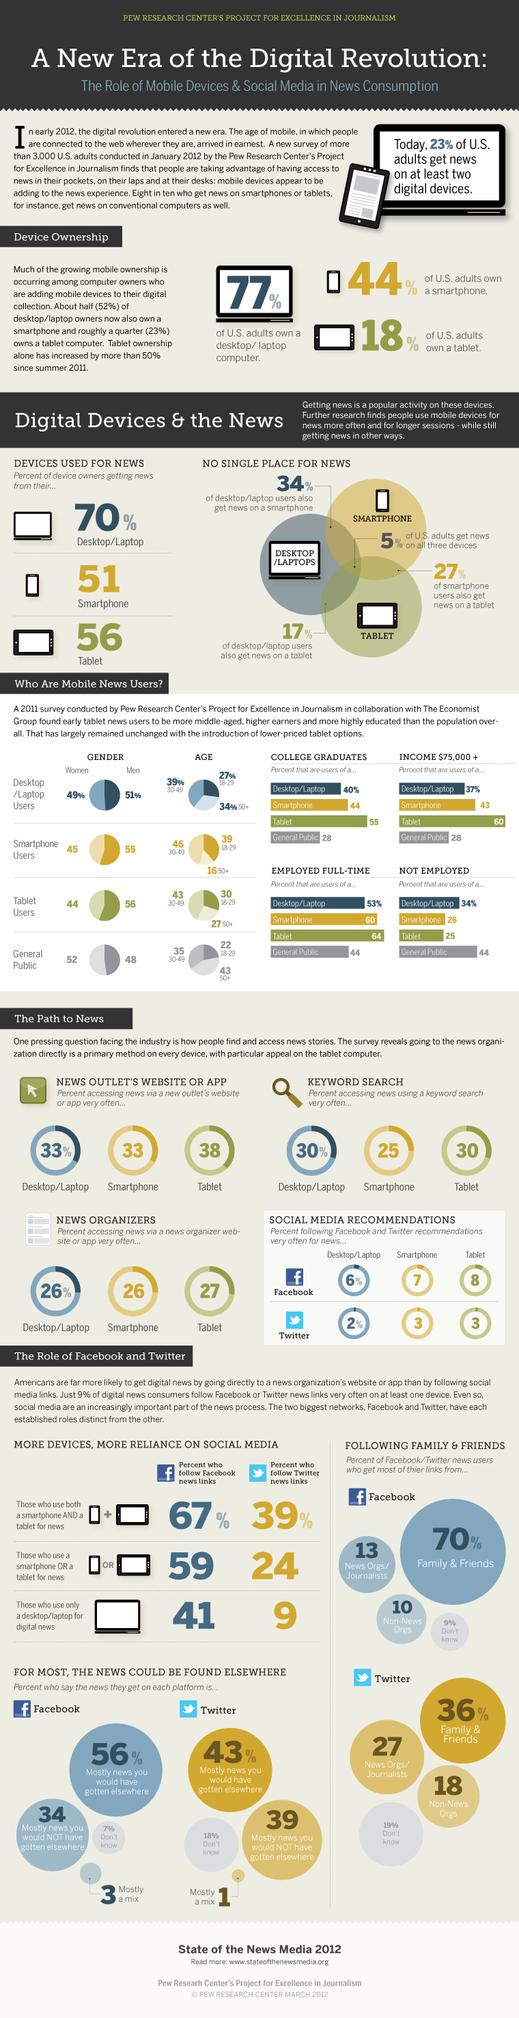Specify some key components in this picture. According to a 2011 survey, 44% of smartphone news users have a college degree. According to a 2011 survey, 51% of desktop/tablet news users in the U.S. are men. According to the 2011 survey, 64% of tablet news users are employed full-time. According to a 2011 survey, approximately 8% of tablet users frequently follow Facebook recommendations for news. According to a survey conducted in the United States in January 2012, approximately 30% of Americans use keyword search on their tablets to access news. 